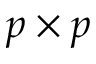<formula> <loc_0><loc_0><loc_500><loc_500>p \times p</formula> 